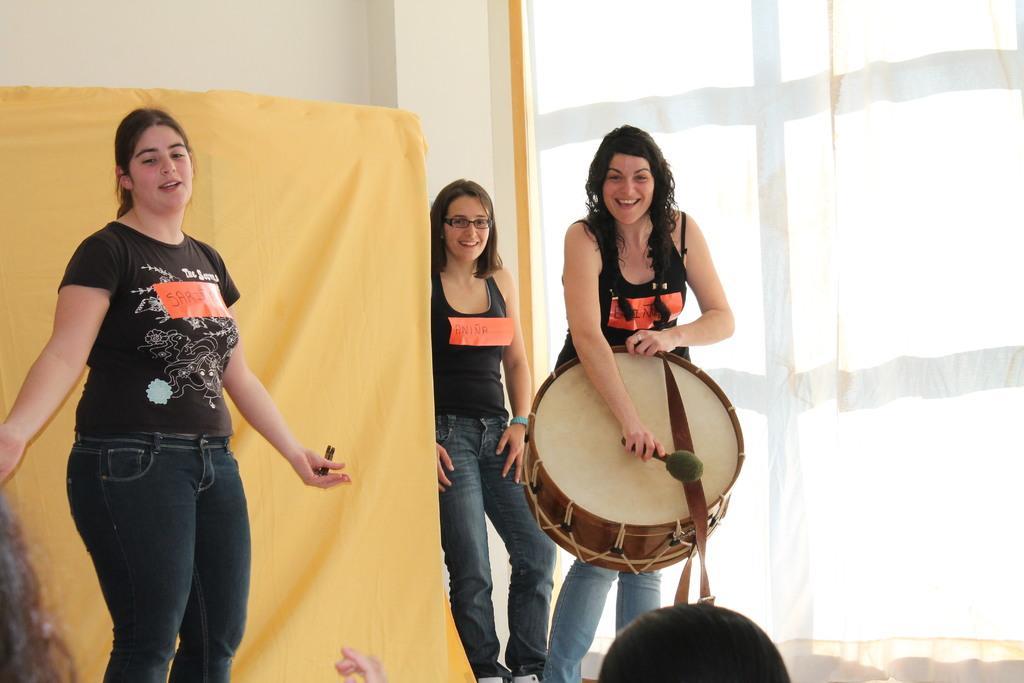Please provide a concise description of this image. There are three women standing and smiling,one woman is holding a drum and playing. This looks like an yellow cloth and This looks like a white cloth hanging. 